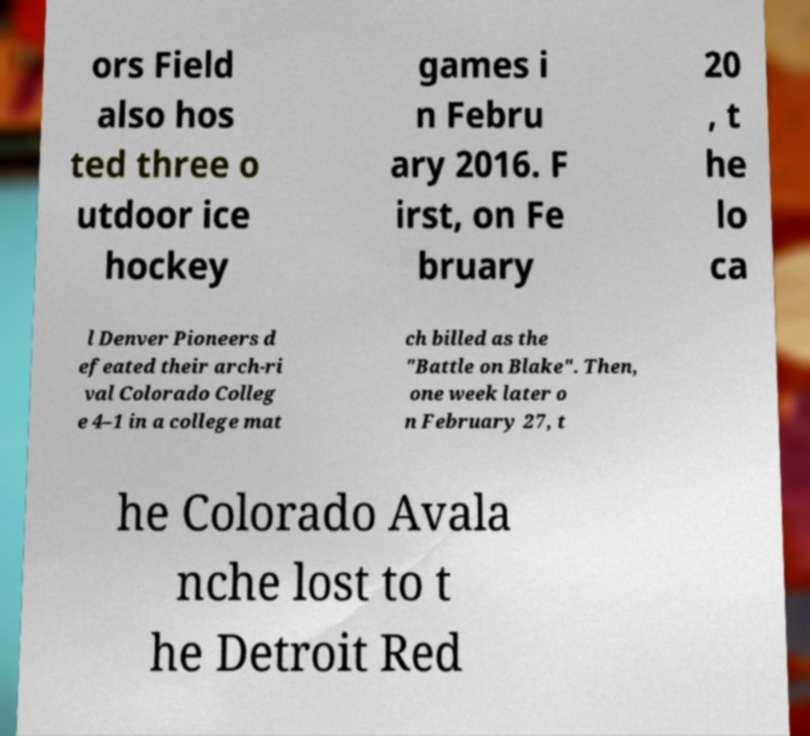Can you read and provide the text displayed in the image?This photo seems to have some interesting text. Can you extract and type it out for me? ors Field also hos ted three o utdoor ice hockey games i n Febru ary 2016. F irst, on Fe bruary 20 , t he lo ca l Denver Pioneers d efeated their arch-ri val Colorado Colleg e 4–1 in a college mat ch billed as the "Battle on Blake". Then, one week later o n February 27, t he Colorado Avala nche lost to t he Detroit Red 